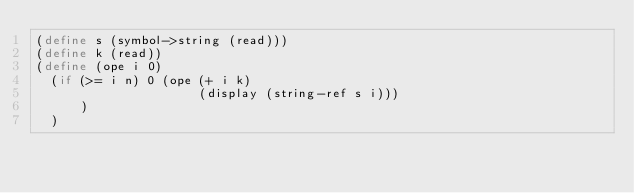<code> <loc_0><loc_0><loc_500><loc_500><_Scheme_>(define s (symbol->string (read)))
(define k (read))
(define (ope i 0)
  (if (>= i n) 0 (ope (+ i k) 
                      (display (string-ref s i)))
      )
  )
</code> 